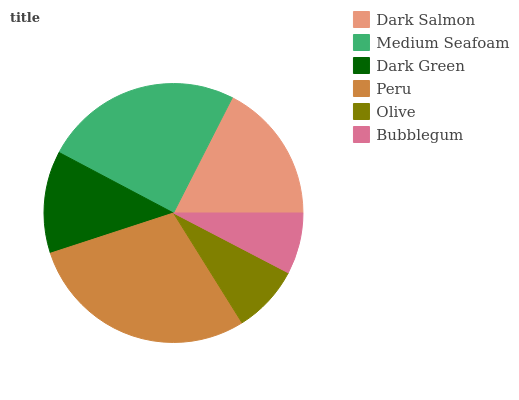Is Bubblegum the minimum?
Answer yes or no. Yes. Is Peru the maximum?
Answer yes or no. Yes. Is Medium Seafoam the minimum?
Answer yes or no. No. Is Medium Seafoam the maximum?
Answer yes or no. No. Is Medium Seafoam greater than Dark Salmon?
Answer yes or no. Yes. Is Dark Salmon less than Medium Seafoam?
Answer yes or no. Yes. Is Dark Salmon greater than Medium Seafoam?
Answer yes or no. No. Is Medium Seafoam less than Dark Salmon?
Answer yes or no. No. Is Dark Salmon the high median?
Answer yes or no. Yes. Is Dark Green the low median?
Answer yes or no. Yes. Is Olive the high median?
Answer yes or no. No. Is Medium Seafoam the low median?
Answer yes or no. No. 